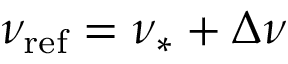<formula> <loc_0><loc_0><loc_500><loc_500>\nu _ { r e f } = \nu _ { \ast } + \Delta \nu</formula> 